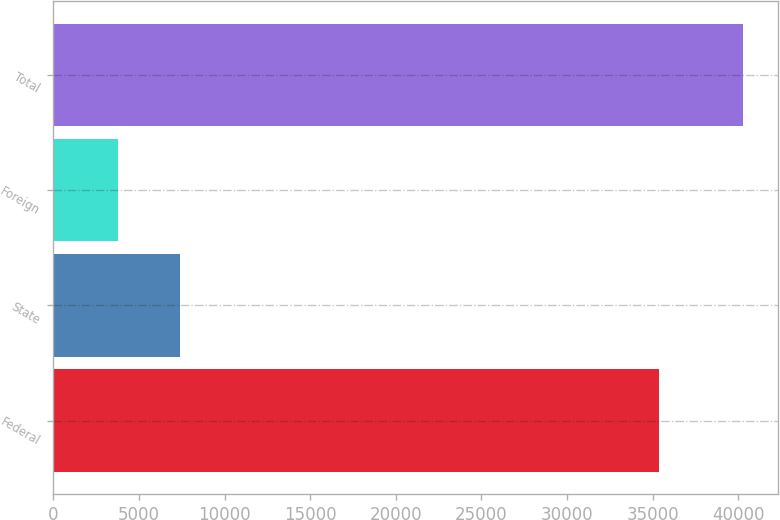Convert chart to OTSL. <chart><loc_0><loc_0><loc_500><loc_500><bar_chart><fcel>Federal<fcel>State<fcel>Foreign<fcel>Total<nl><fcel>35362<fcel>7413.8<fcel>3761<fcel>40289<nl></chart> 